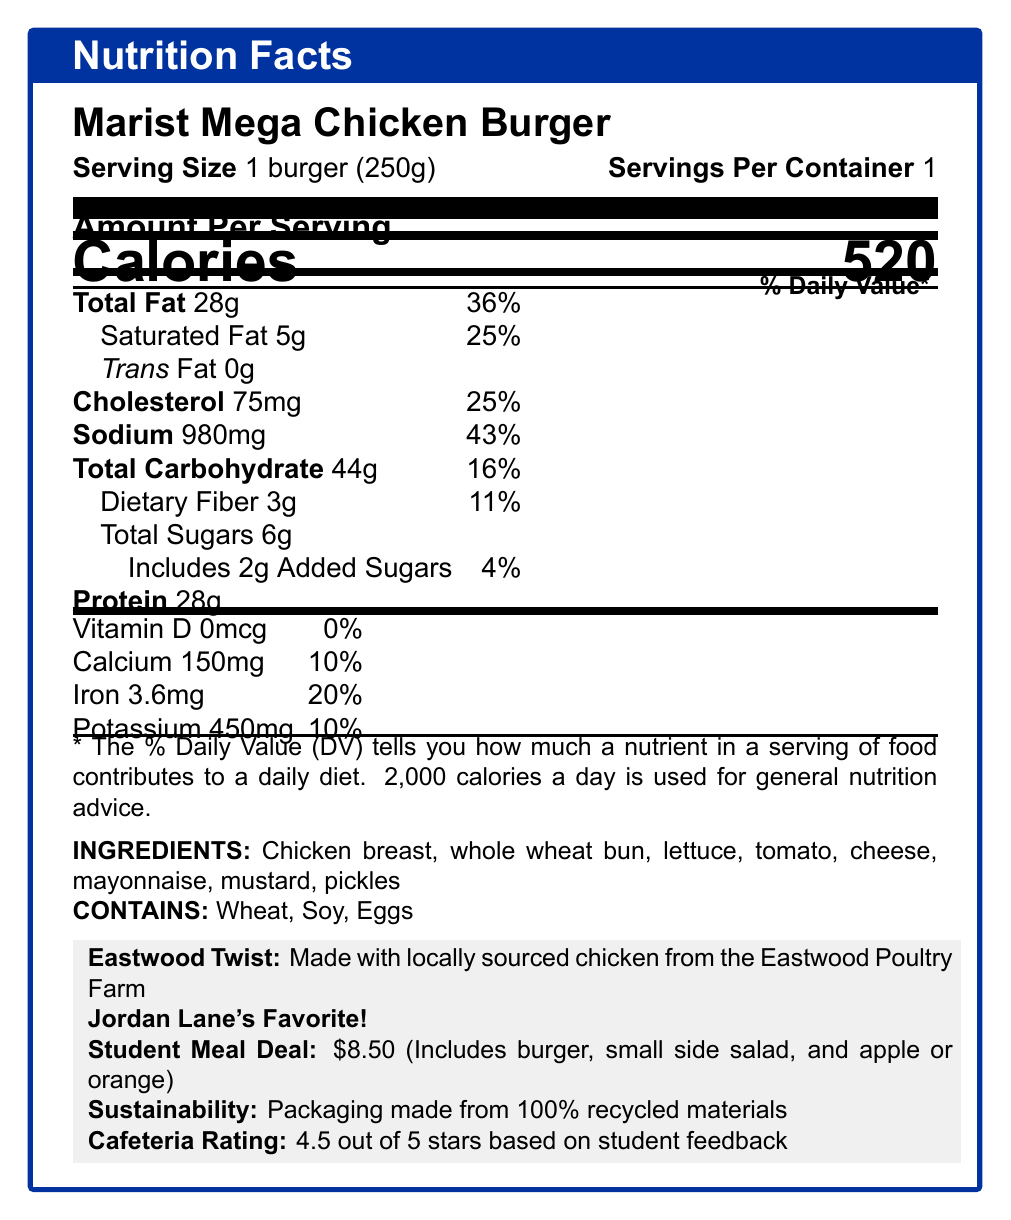What is the serving size of the Marist Mega Chicken Burger? The serving size is clearly stated as "1 burger (250g)" on the document.
Answer: 1 burger (250g) How many calories are in one serving of the Marist Mega Chicken Burger? The document states that one serving contains 520 calories.
Answer: 520 calories How much total fat is in the Marist Mega Chicken Burger? The total fat content is listed as 28g.
Answer: 28g What percentage of the daily value of sodium does the Marist Mega Chicken Burger provide? The daily value percentage for sodium is shown as 43%.
Answer: 43% How much protein does the Marist Mega Chicken Burger contain? The protein content is listed as 28g.
Answer: 28g What are the allergens present in the Marist Mega Chicken Burger? The allergens are listed under "CONTAINS" in the document and specifies Wheat, Soy, and Eggs.
Answer: Wheat, Soy, Eggs Which vitamin is completely absent (0%) in the Marist Mega Chicken Burger? The document shows that Vitamin D has an amount of 0mcg and contributes 0% to the daily value.
Answer: Vitamin D What is included in the student meal deal apart from the Marist Mega Chicken Burger? A. Small side salad B. Apple or orange C. Fries D. Both A and B The student meal deal includes both a small side salad and an apple or orange along with the burger.
Answer: D. Both A and B What is the cost of the student meal deal? A. $7.00 B. $8.50 C. $9.00 D. $10.00 The price of the student meal deal is clearly stated as $8.50.
Answer: B. $8.50 What is the main source of chicken for the Marist Mega Chicken Burger? A. Local grocery store B. Eastwood Poultry Farm C. Imported local market D. None of the above The document specifies that the chicken is locally sourced from the Eastwood Poultry Farm.
Answer: B. Eastwood Poultry Farm Is the Marist Mega Chicken Burger Jordan Lane's favorite? The document explicitly mentions "Jordan Lane's Favorite!"
Answer: Yes Does the packaging of the Marist Mega Chicken Burger support sustainability practices? The document states that the packaging is made from 100% recycled materials.
Answer: Yes Summarize the main features of the Marist Mega Chicken Burger based on the nutrition facts label. The document provides a detailed breakdown of the nutritional content, ingredients, special features, and meal deal options associated with the Marist Mega Chicken Burger.
Answer: The Marist Mega Chicken Burger contains 520 calories per serving, with 28g of total fat and 28g of protein. Key ingredients include chicken breast, whole wheat bun, and various toppings. It is Jordan Lane's favorite and features sustainable packaging. The student meal deal is priced at $8.50 and includes a side salad and an apple or orange. Allergens include wheat, soy, and eggs. What is the exact amount of added sugars in the Marist Mega Chicken Burger? The document lists the added sugars content as 2g.
Answer: 2g Is there any information about the taste or flavor of the Marist Mega Chicken Burger in the document? The document does not provide specific details about the taste or flavor of the burger.
Answer: Not enough information What is the cafeteria rating for the Marist Mega Chicken Burger? Based on student feedback, the cafeteria rating is 4.5 out of 5 stars.
Answer: 4.5 out of 5 stars 